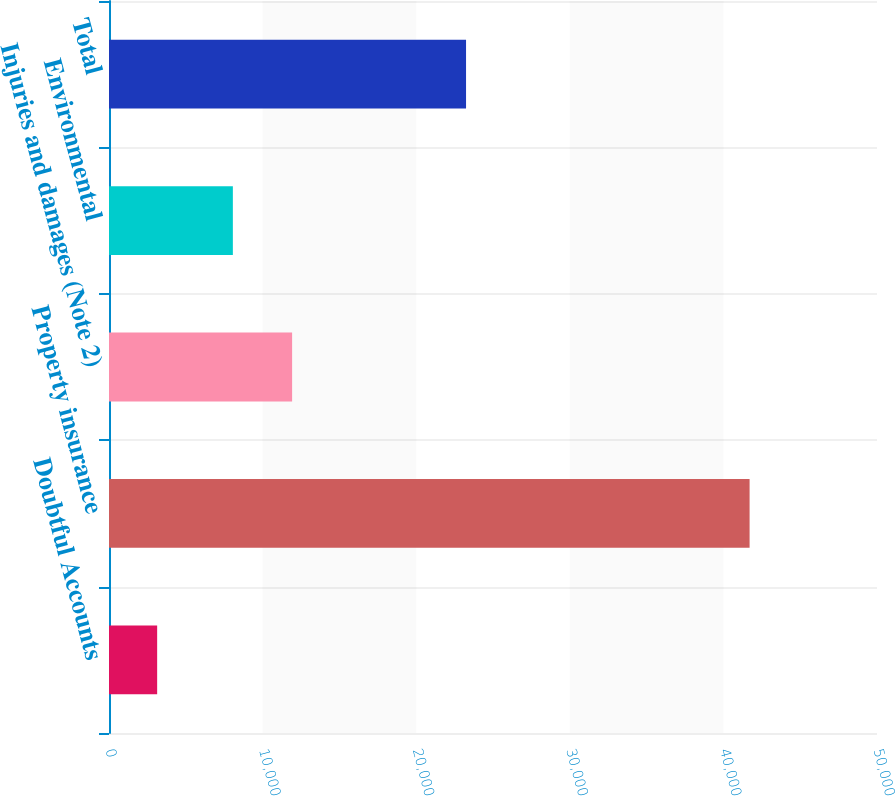Convert chart. <chart><loc_0><loc_0><loc_500><loc_500><bar_chart><fcel>Doubtful Accounts<fcel>Property insurance<fcel>Injuries and damages (Note 2)<fcel>Environmental<fcel>Total<nl><fcel>3135<fcel>41705<fcel>11921<fcel>8064<fcel>23245<nl></chart> 